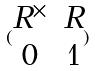Convert formula to latex. <formula><loc_0><loc_0><loc_500><loc_500>( \begin{matrix} R ^ { \times } & R \\ 0 & 1 \end{matrix} )</formula> 